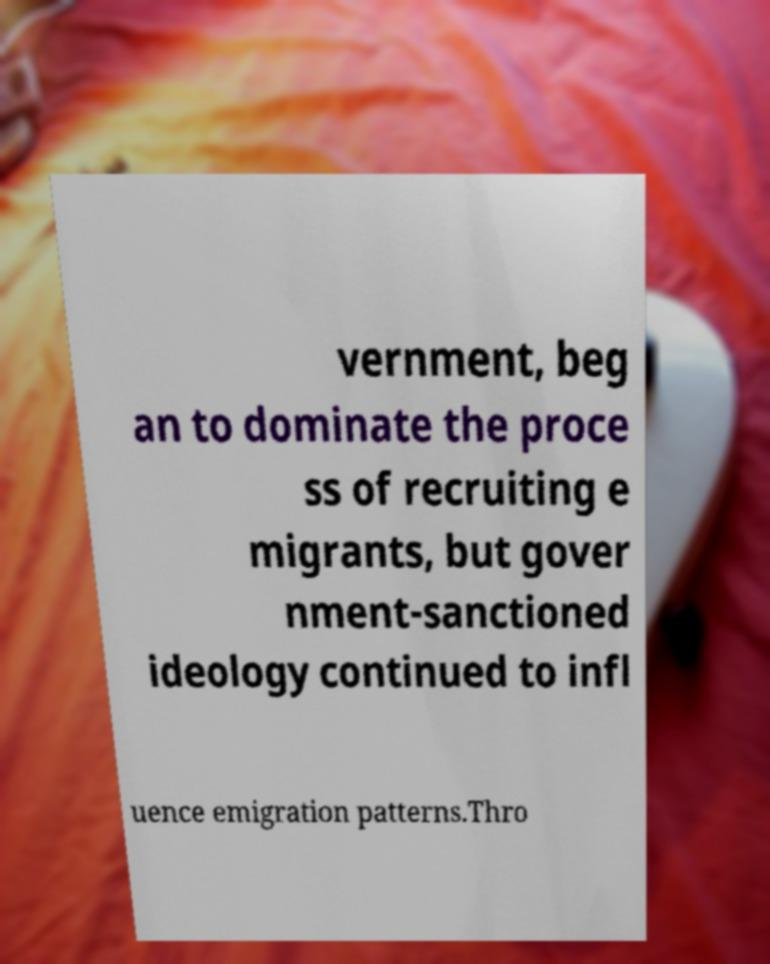There's text embedded in this image that I need extracted. Can you transcribe it verbatim? vernment, beg an to dominate the proce ss of recruiting e migrants, but gover nment-sanctioned ideology continued to infl uence emigration patterns.Thro 